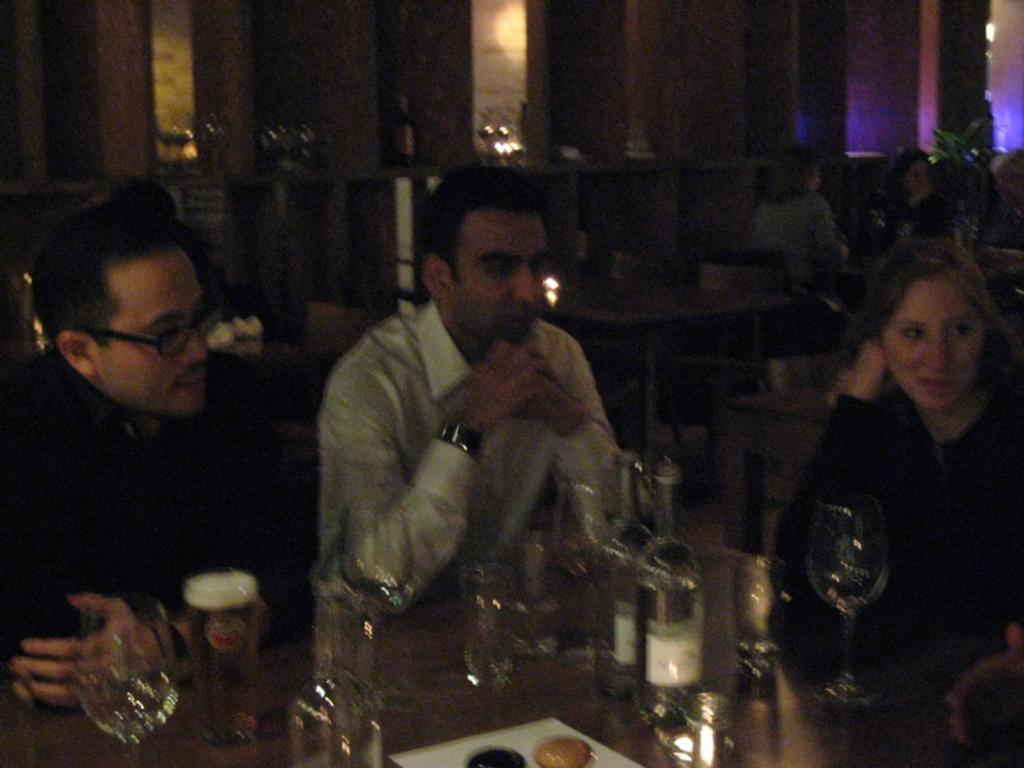What are the people in the image doing? The people in the image are sitting on chairs. What can be seen on the table in the image? There are wine bottles and wine glasses on the table. Are there any other people visible in the image? Yes, there are other women sitting on chairs in the background. What type of harbor can be seen in the image? There is no harbor present in the image. What is the degree of the beam used in the image? There is no beam present in the image. 